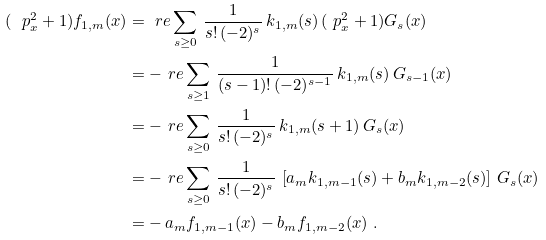Convert formula to latex. <formula><loc_0><loc_0><loc_500><loc_500>( \ p _ { x } ^ { 2 } + 1 ) f _ { 1 , m } ( x ) & = \ r e \sum _ { s \geq 0 } \, \frac { 1 } { s ! \, ( - 2 ) ^ { s } } \, k _ { 1 , m } ( s ) \, ( \ p _ { x } ^ { 2 } + 1 ) G _ { s } ( x ) \\ & = - \ r e \sum _ { s \geq 1 } \, \frac { 1 } { ( s - 1 ) ! \, ( - 2 ) ^ { s - 1 } } \, k _ { 1 , m } ( s ) \, G _ { s - 1 } ( x ) \\ & = - \ r e \sum _ { s \geq 0 } \, \frac { 1 } { s ! \, ( - 2 ) ^ { s } } \, k _ { 1 , m } ( s + 1 ) \, G _ { s } ( x ) \\ & = - \ r e \sum _ { s \geq 0 } \, \frac { 1 } { s ! \, ( - 2 ) ^ { s } } \, \left [ a _ { m } k _ { 1 , m - 1 } ( s ) + b _ { m } k _ { 1 , m - 2 } ( s ) \right ] \, G _ { s } ( x ) \\ & = - \, a _ { m } f _ { 1 , m - 1 } ( x ) - b _ { m } f _ { 1 , m - 2 } ( x ) \ .</formula> 